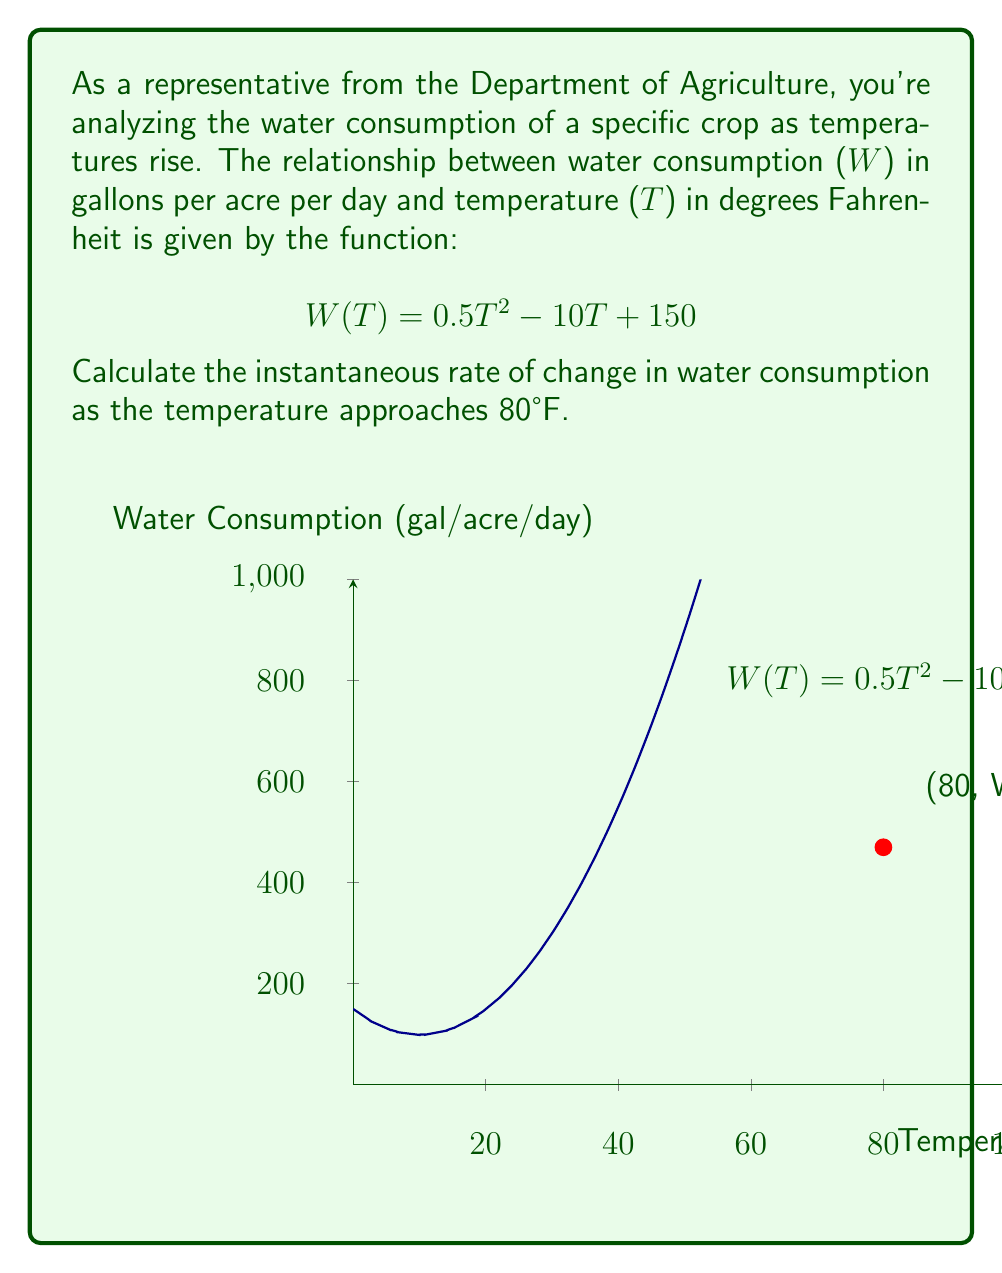Give your solution to this math problem. To find the instantaneous rate of change as the temperature approaches 80°F, we need to calculate the limit of the difference quotient as h approaches 0:

1) The limit definition of the derivative:
   $$\lim_{h \to 0} \frac{W(80+h) - W(80)}{h}$$

2) Substitute the function:
   $$\lim_{h \to 0} \frac{[0.5(80+h)^2 - 10(80+h) + 150] - [0.5(80)^2 - 10(80) + 150]}{h}$$

3) Expand the squared term:
   $$\lim_{h \to 0} \frac{[0.5(6400+160h+h^2) - 800 - 10h + 150] - [3200 - 800 + 150]}{h}$$

4) Simplify:
   $$\lim_{h \to 0} \frac{3200+80h+0.5h^2 - 800 - 10h + 150 - 2550}{h}$$
   $$\lim_{h \to 0} \frac{80h+0.5h^2 - 10h}{h}$$

5) Factor out h:
   $$\lim_{h \to 0} \frac{h(80+0.5h - 10)}{h}$$

6) Cancel h:
   $$\lim_{h \to 0} (80+0.5h - 10)$$

7) Evaluate the limit:
   $$80 + 0.5(0) - 10 = 70$$

Therefore, the instantaneous rate of change in water consumption as the temperature approaches 80°F is 70 gallons per acre per day per degree Fahrenheit.
Answer: 70 gal/acre/day/°F 